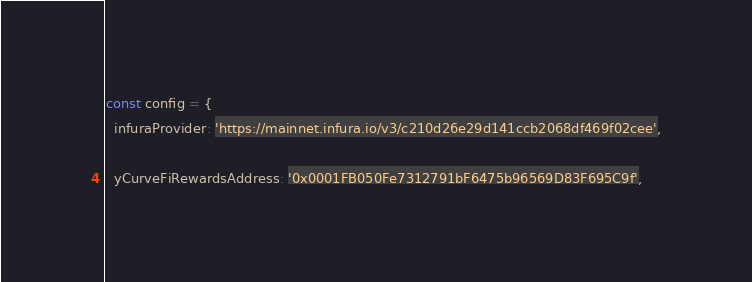<code> <loc_0><loc_0><loc_500><loc_500><_JavaScript_>const config = {
  infuraProvider: 'https://mainnet.infura.io/v3/c210d26e29d141ccb2068df469f02cee',

  yCurveFiRewardsAddress: '0x0001FB050Fe7312791bF6475b96569D83F695C9f',</code> 